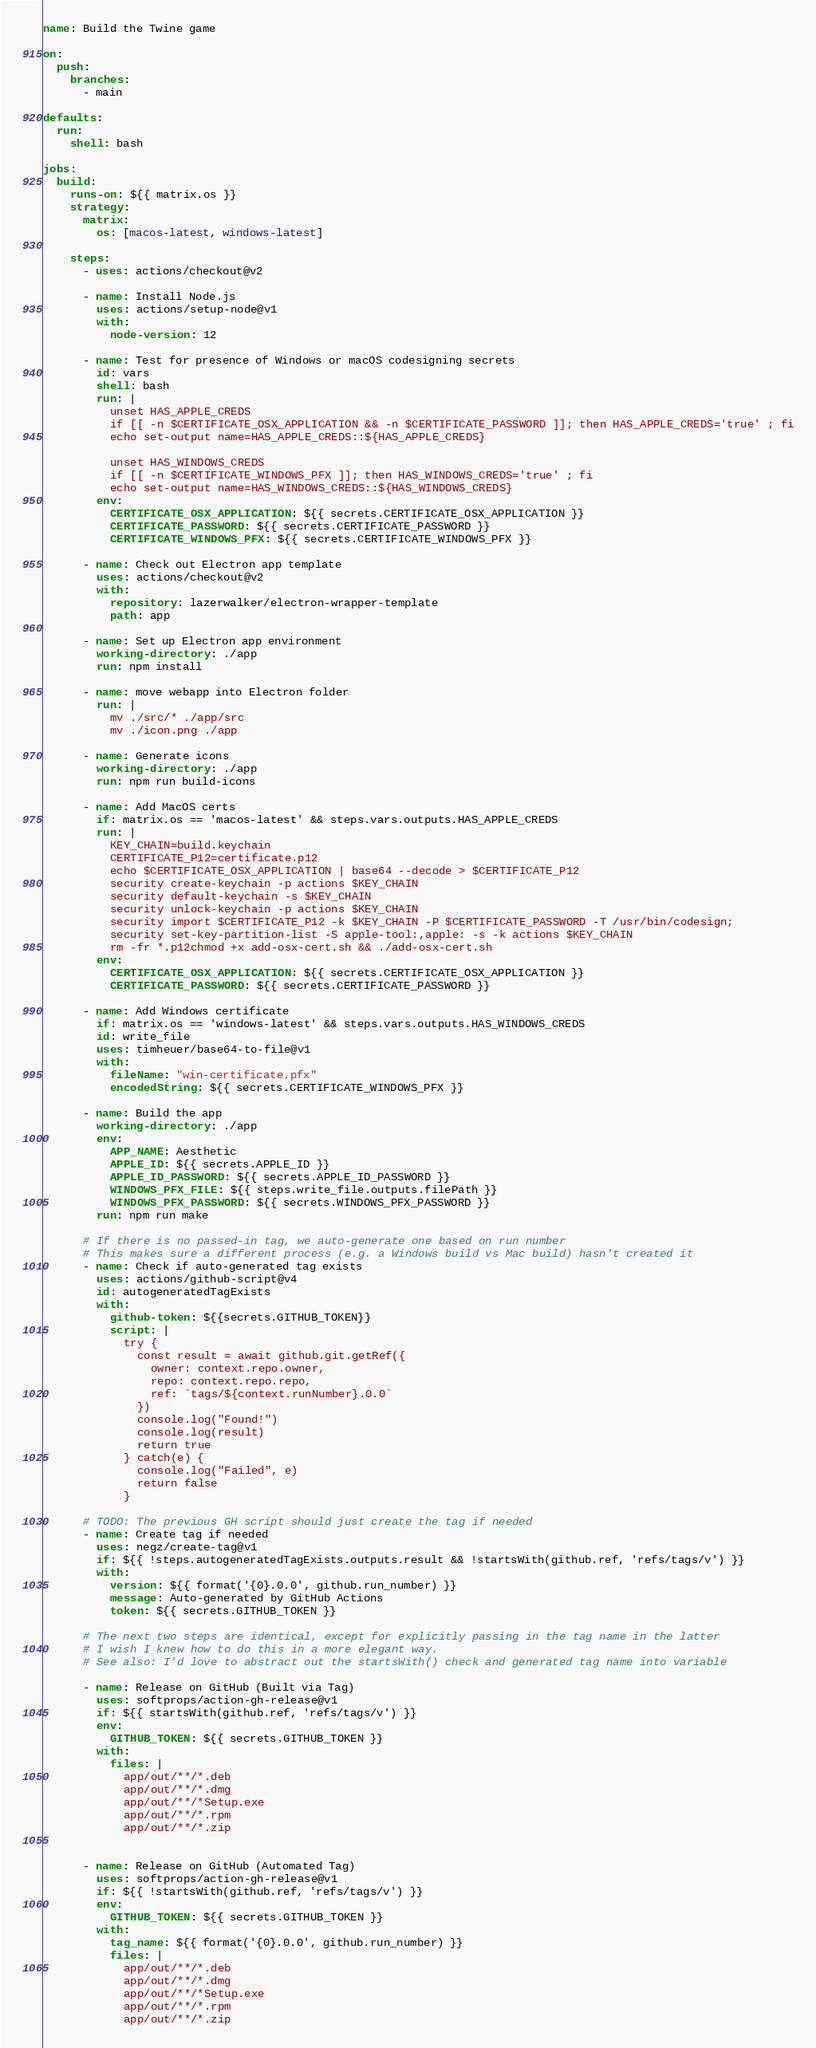Convert code to text. <code><loc_0><loc_0><loc_500><loc_500><_YAML_>name: Build the Twine game

on:
  push:
    branches:
      - main

defaults:
  run:
    shell: bash

jobs:
  build:
    runs-on: ${{ matrix.os }}
    strategy:
      matrix:
        os: [macos-latest, windows-latest]

    steps:
      - uses: actions/checkout@v2

      - name: Install Node.js
        uses: actions/setup-node@v1
        with:
          node-version: 12

      - name: Test for presence of Windows or macOS codesigning secrets
        id: vars
        shell: bash
        run: |
          unset HAS_APPLE_CREDS
          if [[ -n $CERTIFICATE_OSX_APPLICATION && -n $CERTIFICATE_PASSWORD ]]; then HAS_APPLE_CREDS='true' ; fi
          echo set-output name=HAS_APPLE_CREDS::${HAS_APPLE_CREDS}

          unset HAS_WINDOWS_CREDS
          if [[ -n $CERTIFICATE_WINDOWS_PFX ]]; then HAS_WINDOWS_CREDS='true' ; fi
          echo set-output name=HAS_WINDOWS_CREDS::${HAS_WINDOWS_CREDS}
        env:
          CERTIFICATE_OSX_APPLICATION: ${{ secrets.CERTIFICATE_OSX_APPLICATION }}
          CERTIFICATE_PASSWORD: ${{ secrets.CERTIFICATE_PASSWORD }}
          CERTIFICATE_WINDOWS_PFX: ${{ secrets.CERTIFICATE_WINDOWS_PFX }}

      - name: Check out Electron app template
        uses: actions/checkout@v2
        with:
          repository: lazerwalker/electron-wrapper-template
          path: app

      - name: Set up Electron app environment
        working-directory: ./app
        run: npm install

      - name: move webapp into Electron folder
        run: |
          mv ./src/* ./app/src
          mv ./icon.png ./app

      - name: Generate icons
        working-directory: ./app
        run: npm run build-icons

      - name: Add MacOS certs
        if: matrix.os == 'macos-latest' && steps.vars.outputs.HAS_APPLE_CREDS
        run: |
          KEY_CHAIN=build.keychain
          CERTIFICATE_P12=certificate.p12
          echo $CERTIFICATE_OSX_APPLICATION | base64 --decode > $CERTIFICATE_P12
          security create-keychain -p actions $KEY_CHAIN
          security default-keychain -s $KEY_CHAIN
          security unlock-keychain -p actions $KEY_CHAIN
          security import $CERTIFICATE_P12 -k $KEY_CHAIN -P $CERTIFICATE_PASSWORD -T /usr/bin/codesign;
          security set-key-partition-list -S apple-tool:,apple: -s -k actions $KEY_CHAIN
          rm -fr *.p12chmod +x add-osx-cert.sh && ./add-osx-cert.sh
        env:
          CERTIFICATE_OSX_APPLICATION: ${{ secrets.CERTIFICATE_OSX_APPLICATION }}
          CERTIFICATE_PASSWORD: ${{ secrets.CERTIFICATE_PASSWORD }}

      - name: Add Windows certificate
        if: matrix.os == 'windows-latest' && steps.vars.outputs.HAS_WINDOWS_CREDS
        id: write_file
        uses: timheuer/base64-to-file@v1
        with:
          fileName: "win-certificate.pfx"
          encodedString: ${{ secrets.CERTIFICATE_WINDOWS_PFX }}

      - name: Build the app
        working-directory: ./app
        env:
          APP_NAME: Aesthetic
          APPLE_ID: ${{ secrets.APPLE_ID }}
          APPLE_ID_PASSWORD: ${{ secrets.APPLE_ID_PASSWORD }}
          WINDOWS_PFX_FILE: ${{ steps.write_file.outputs.filePath }}
          WINDOWS_PFX_PASSWORD: ${{ secrets.WINDOWS_PFX_PASSWORD }}
        run: npm run make

      # If there is no passed-in tag, we auto-generate one based on run number
      # This makes sure a different process (e.g. a Windows build vs Mac build) hasn't created it
      - name: Check if auto-generated tag exists
        uses: actions/github-script@v4
        id: autogeneratedTagExists
        with:
          github-token: ${{secrets.GITHUB_TOKEN}}
          script: |
            try {
              const result = await github.git.getRef({
                owner: context.repo.owner,
                repo: context.repo.repo,
                ref: `tags/${context.runNumber}.0.0`
              })
              console.log("Found!")
              console.log(result)
              return true
            } catch(e) {
              console.log("Failed", e)
              return false
            }

      # TODO: The previous GH script should just create the tag if needed
      - name: Create tag if needed
        uses: negz/create-tag@v1
        if: ${{ !steps.autogeneratedTagExists.outputs.result && !startsWith(github.ref, 'refs/tags/v') }}
        with:
          version: ${{ format('{0}.0.0', github.run_number) }}
          message: Auto-generated by GitHub Actions
          token: ${{ secrets.GITHUB_TOKEN }}

      # The next two steps are identical, except for explicitly passing in the tag name in the latter
      # I wish I knew how to do this in a more elegant way.
      # See also: I'd love to abstract out the startsWith() check and generated tag name into variable

      - name: Release on GitHub (Built via Tag)
        uses: softprops/action-gh-release@v1
        if: ${{ startsWith(github.ref, 'refs/tags/v') }}
        env:
          GITHUB_TOKEN: ${{ secrets.GITHUB_TOKEN }}
        with:
          files: |
            app/out/**/*.deb
            app/out/**/*.dmg
            app/out/**/*Setup.exe
            app/out/**/*.rpm
            app/out/**/*.zip


      - name: Release on GitHub (Automated Tag)
        uses: softprops/action-gh-release@v1
        if: ${{ !startsWith(github.ref, 'refs/tags/v') }}
        env:
          GITHUB_TOKEN: ${{ secrets.GITHUB_TOKEN }}
        with:
          tag_name: ${{ format('{0}.0.0', github.run_number) }}
          files: |
            app/out/**/*.deb
            app/out/**/*.dmg
            app/out/**/*Setup.exe
            app/out/**/*.rpm
            app/out/**/*.zip
</code> 